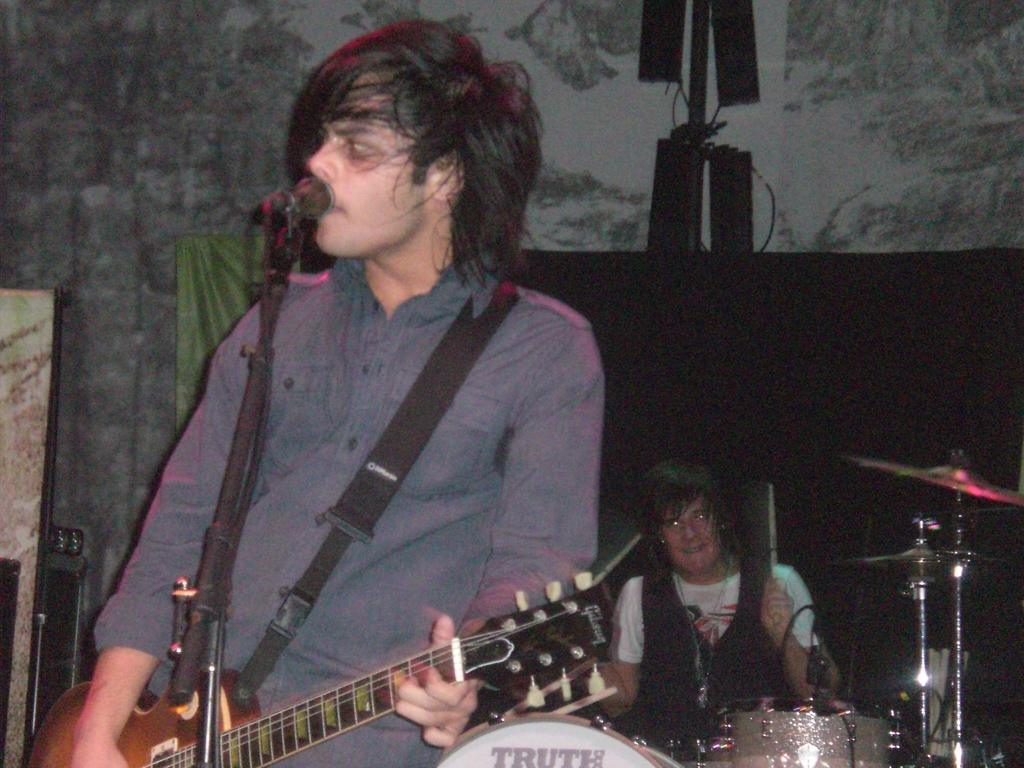Describe this image in one or two sentences. In this picture there is a man who is playing a guitar and singing on a mic. On the bottom there is a woman who is smiling. We can see there is a musical instrument. On the background we can see a cloth. 